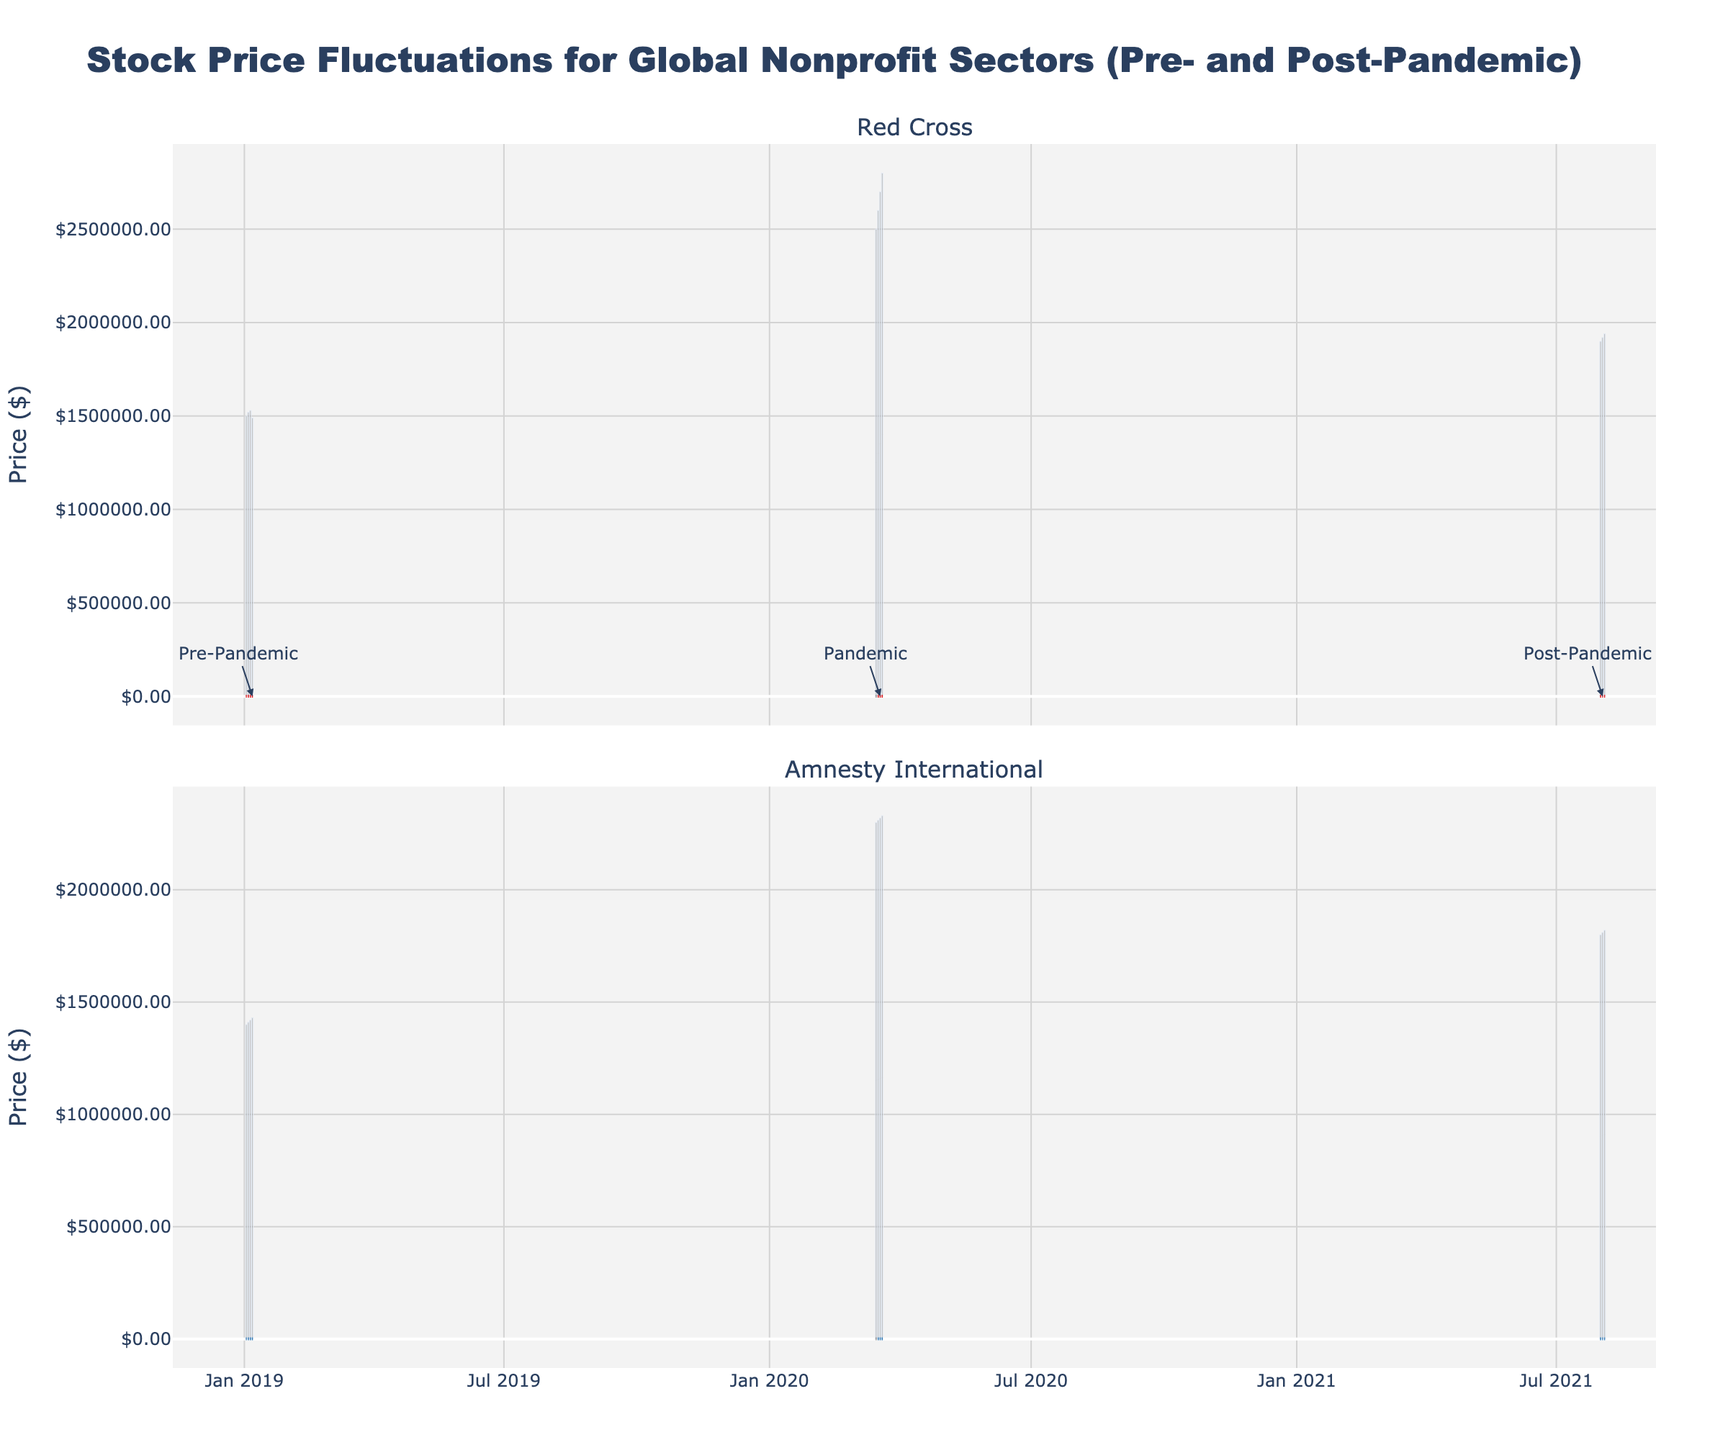What is the title of the plot? The title of the plot is written in large, prominent text at the top of the figure. It reads "Stock Price Fluctuations for Global Nonprofit Sectors (Pre- and Post-Pandemic)."
Answer: Stock Price Fluctuations for Global Nonprofit Sectors (Pre- and Post-Pandemic) What organizations are compared in the plot? Each subplot is titled with the name of an organization. The two organizations compared are "Red Cross" and "Amnesty International."
Answer: Red Cross and Amnesty International What is the y-axis label in the plot? The y-axis label appears on the vertical axis of both subplots. It is titled "Price ($)."
Answer: Price ($) How many annotations are present in the plot? The figure contains annotations marked by arrows and text labels. There are three annotations: "Pre-Pandemic," "Pandemic," and "Post-Pandemic."
Answer: Three What colors represent the candlestick charts for each organization? The colors of the candlestick charts are provided in the visual legend of the candlesticks. "Red Cross" is represented by red candlesticks, and "Amnesty International" is represented by blue candlesticks.
Answer: Red for Red Cross, blue for Amnesty International What volume of shares was traded on March 18, 2020, for both organizations? Total volume can be calculated by summing the volumes for each organization on March 18, 2020. For "Red Cross": 2,700,000 and for "Amnesty International": 2,320,000. The total is 2,700,000 + 2,320,000 = 5,020,000 shares.
Answer: 5,020,000 shares What is the average closing price for the "Red Cross" in August 2021? Calculate the average by adding the closing prices and dividing by the number of days. The closing prices are 45.80, 46.00, and 46.20. The sum is 45.80 + 46.00 + 46.20 = 138.00. The average is 138.00 / 3 ≈ 46.00.
Answer: 46.00 How did the closing price of "Amnesty International" change from January 2, 2019, to August 4, 2021? First, identify the closing prices on January 2, 2019 (40.60), and August 4, 2021 (36.20). The change is calculated as 36.20 - 40.60 = -4.40.
Answer: -4.40 Which organization had a higher closing price on March 16, 2020? By comparing the closing prices on March 16, 2020, for both organizations: "Red Cross" closed at 30.00 and "Amnesty International" closed at 25.00. "Red Cross" had the higher closing price.
Answer: Red Cross Did the stock price of "Red Cross" increase or decrease from January 2, 2019, to January 7, 2019? By comparing the closing prices on January 2 (50.60) and January 7 (51.80), the price increased. The difference is 51.80 - 50.60 = 1.20.
Answer: Increase Which organization had a smaller decrease in stock price from the pre-pandemic to the pandemic period? First, determine the closing prices just before and during the pandemic for both organizations. For "Red Cross": January 7, 2019 (51.80) to March 16, 2020 (30.00), a decrease of 21.80. For "Amnesty International": January 7, 2019 (41.80) to March 16, 2020 (25.00), a decrease of 16.80. "Amnesty International" had a smaller decrease.
Answer: Amnesty International What is the high price for "Red Cross" on August 3, 2021? The high price can be identified from the candlestick for the specific date, August 3, 2021. The high price is 46.20.
Answer: 46.20 How does the volume of shares traded on August 4, 2021, for "Amnesty International" compare to the volume on January 2, 2019? Compare the volume of shares traded: August 4, 2021 had 1,820,000 shares traded, and January 2, 2019 had 1,400,000 shares traded. There was an increase of 1,820,000 - 1,400,000 = 420,000 shares.
Answer: Increase of 420,000 shares 